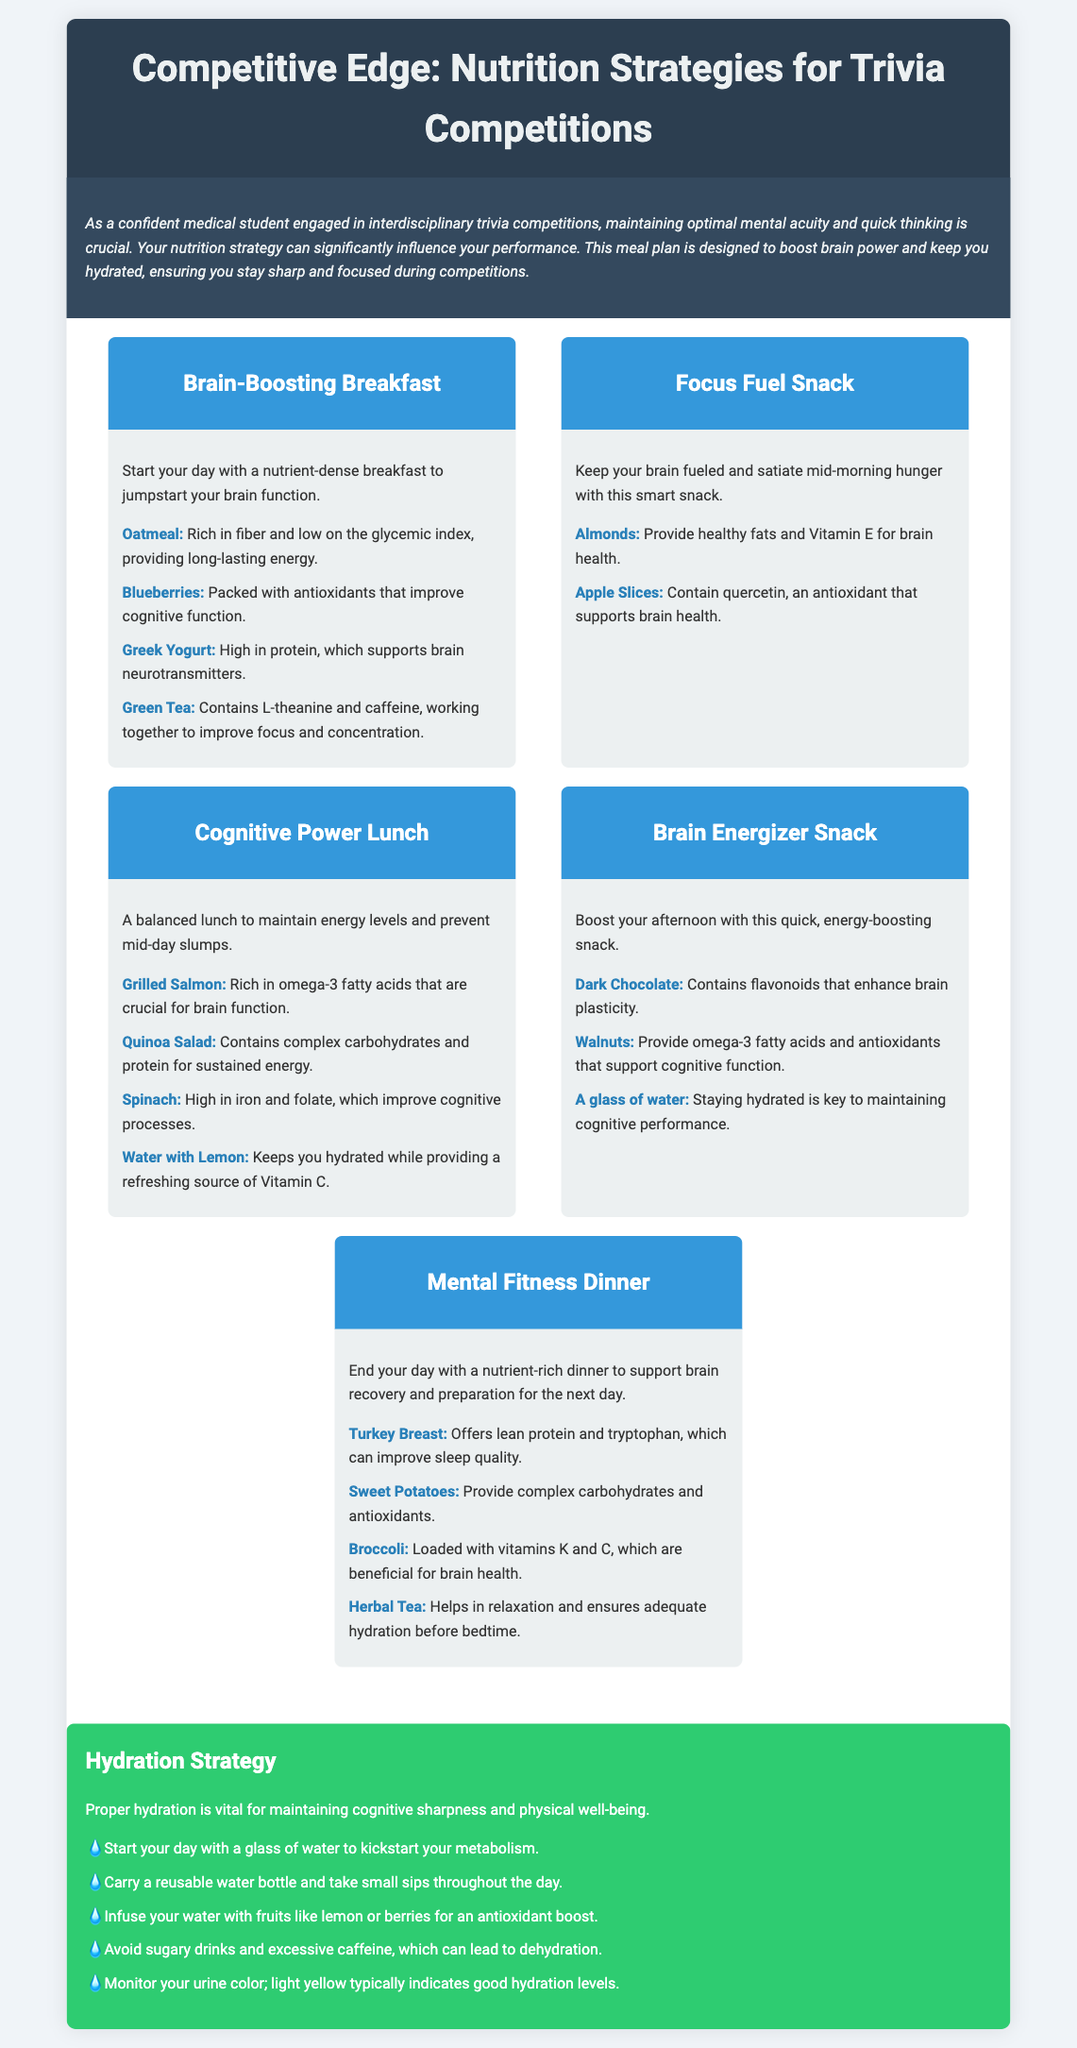What is the title of the document? The title of the document appears at the top of the rendered document, stating the purpose of the content.
Answer: Competitive Edge: Nutrition Strategies for Trivia Competitions What is one of the brain-boosting foods mentioned for breakfast? This information is found in the breakfast section of the meal plan, which lists foods that promote brain function.
Answer: Oatmeal How many meals are outlined in the meal plan? The meal plan lists five distinct meals to help maintain energy and focus.
Answer: Five Which drink is suggested for hydration during lunch? The lunch section specifies a particular beverage that aids in hydration alongside the meal.
Answer: Water with Lemon What is one of the hydration strategies provided? The hydration section includes practical tips for maintaining hydration levels, which can aid cognitive function.
Answer: Start your day with a glass of water Which nutrient-rich food is recommended for dinner? The dinner section highlights food choices that support brain recovery, including a specific lean protein.
Answer: Turkey Breast What is the color of urine that typically indicates good hydration levels? The hydration strategies section mentions a specific color to monitor for indicating proper hydration.
Answer: Light yellow Name a fruit suggested for infusing water. The hydration strategy mentions utilizing fruits to enhance water intake, promoting better hydration.
Answer: Lemon 